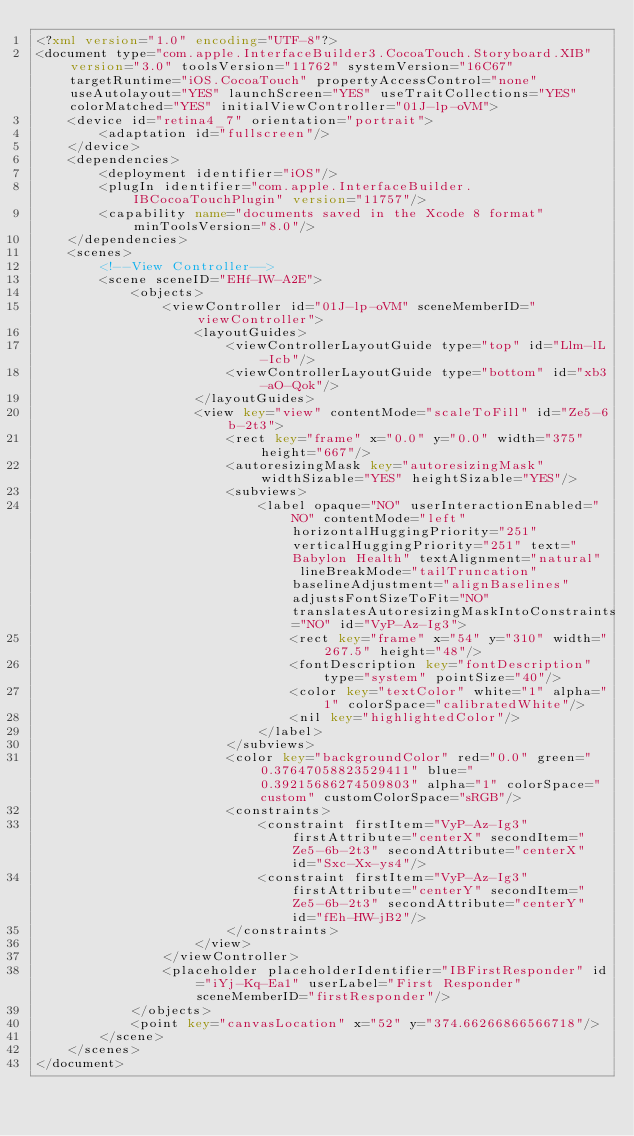Convert code to text. <code><loc_0><loc_0><loc_500><loc_500><_XML_><?xml version="1.0" encoding="UTF-8"?>
<document type="com.apple.InterfaceBuilder3.CocoaTouch.Storyboard.XIB" version="3.0" toolsVersion="11762" systemVersion="16C67" targetRuntime="iOS.CocoaTouch" propertyAccessControl="none" useAutolayout="YES" launchScreen="YES" useTraitCollections="YES" colorMatched="YES" initialViewController="01J-lp-oVM">
    <device id="retina4_7" orientation="portrait">
        <adaptation id="fullscreen"/>
    </device>
    <dependencies>
        <deployment identifier="iOS"/>
        <plugIn identifier="com.apple.InterfaceBuilder.IBCocoaTouchPlugin" version="11757"/>
        <capability name="documents saved in the Xcode 8 format" minToolsVersion="8.0"/>
    </dependencies>
    <scenes>
        <!--View Controller-->
        <scene sceneID="EHf-IW-A2E">
            <objects>
                <viewController id="01J-lp-oVM" sceneMemberID="viewController">
                    <layoutGuides>
                        <viewControllerLayoutGuide type="top" id="Llm-lL-Icb"/>
                        <viewControllerLayoutGuide type="bottom" id="xb3-aO-Qok"/>
                    </layoutGuides>
                    <view key="view" contentMode="scaleToFill" id="Ze5-6b-2t3">
                        <rect key="frame" x="0.0" y="0.0" width="375" height="667"/>
                        <autoresizingMask key="autoresizingMask" widthSizable="YES" heightSizable="YES"/>
                        <subviews>
                            <label opaque="NO" userInteractionEnabled="NO" contentMode="left" horizontalHuggingPriority="251" verticalHuggingPriority="251" text="Babylon Health" textAlignment="natural" lineBreakMode="tailTruncation" baselineAdjustment="alignBaselines" adjustsFontSizeToFit="NO" translatesAutoresizingMaskIntoConstraints="NO" id="VyP-Az-Ig3">
                                <rect key="frame" x="54" y="310" width="267.5" height="48"/>
                                <fontDescription key="fontDescription" type="system" pointSize="40"/>
                                <color key="textColor" white="1" alpha="1" colorSpace="calibratedWhite"/>
                                <nil key="highlightedColor"/>
                            </label>
                        </subviews>
                        <color key="backgroundColor" red="0.0" green="0.37647058823529411" blue="0.39215686274509803" alpha="1" colorSpace="custom" customColorSpace="sRGB"/>
                        <constraints>
                            <constraint firstItem="VyP-Az-Ig3" firstAttribute="centerX" secondItem="Ze5-6b-2t3" secondAttribute="centerX" id="Sxc-Xx-ys4"/>
                            <constraint firstItem="VyP-Az-Ig3" firstAttribute="centerY" secondItem="Ze5-6b-2t3" secondAttribute="centerY" id="fEh-HW-jB2"/>
                        </constraints>
                    </view>
                </viewController>
                <placeholder placeholderIdentifier="IBFirstResponder" id="iYj-Kq-Ea1" userLabel="First Responder" sceneMemberID="firstResponder"/>
            </objects>
            <point key="canvasLocation" x="52" y="374.66266866566718"/>
        </scene>
    </scenes>
</document>
</code> 